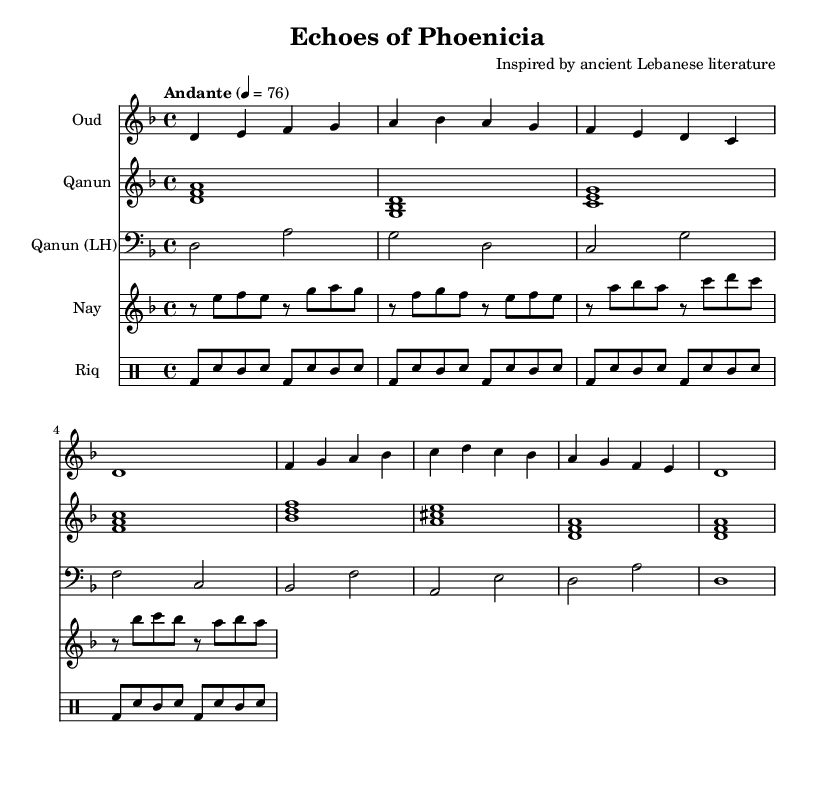What is the key signature of this music? The key signature is D minor, which contains one flat (B flat). This can be determined by looking at the key signature indicated at the beginning of the score.
Answer: D minor What is the time signature of this piece? The time signature is 4/4, as indicated at the beginning of the score. This means there are four beats per measure, and a quarter note receives one beat.
Answer: 4/4 What is the tempo marking for this composition? The tempo marking is Andante, which indicates a moderate walking pace. It is listed at the start of the music, along with the metronome marking of 76 beats per minute.
Answer: Andante How many instruments are indicated in the score? The score lists five instruments: Oud, Qanun, Qanun (LH), Nay, and Riq. This can be seen by counting the unique staffs in the score.
Answer: Five Which instrument is associated with the bass clef? The bass clef is associated with the Qanun (LH), which indicates that this part is played in a lower register than the other Qanun staff. This is observable by the clef symbol used for that staff.
Answer: Qanun (LH) What type of music does this composition represent? This composition represents Classical Arabic music, as it is inspired by ancient Lebanese literature and utilizes traditional Middle Eastern instruments. This can be inferred from the title and instrument choices.
Answer: Classical Arabic music 